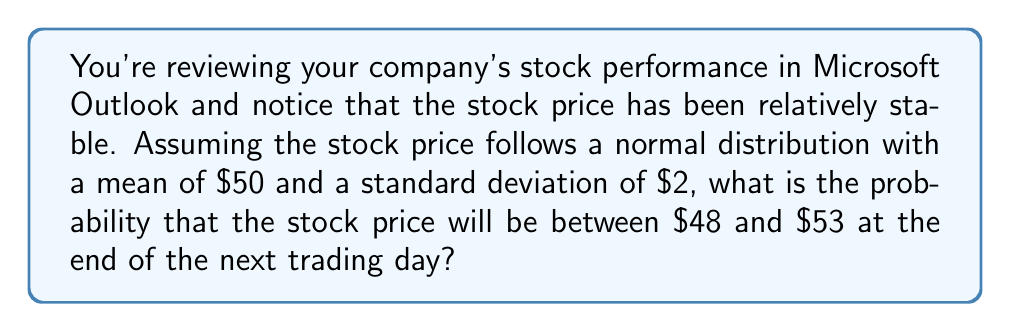Solve this math problem. To solve this problem, we'll use the properties of the normal distribution and the z-score formula. Let's break it down step-by-step:

1) First, we need to calculate the z-scores for both $48 and $53. The z-score formula is:

   $$ z = \frac{x - \mu}{\sigma} $$

   Where $x$ is the value, $\mu$ is the mean, and $\sigma$ is the standard deviation.

2) For $x = 48$:
   $$ z_1 = \frac{48 - 50}{2} = -1 $$

3) For $x = 53$:
   $$ z_2 = \frac{53 - 50}{2} = 1.5 $$

4) Now, we need to find the area under the standard normal curve between these two z-scores. This can be done using a standard normal table or a calculator with a built-in normal distribution function.

5) The probability is:
   $$ P(48 < X < 53) = P(-1 < Z < 1.5) = \Phi(1.5) - \Phi(-1) $$

   Where $\Phi(z)$ is the cumulative distribution function of the standard normal distribution.

6) Using a standard normal table or calculator:
   $$ \Phi(1.5) \approx 0.9332 $$
   $$ \Phi(-1) \approx 0.1587 $$

7) Therefore, the probability is:
   $$ 0.9332 - 0.1587 = 0.7745 $$
Answer: The probability that the stock price will be between $48 and $53 at the end of the next trading day is approximately 0.7745 or 77.45%. 